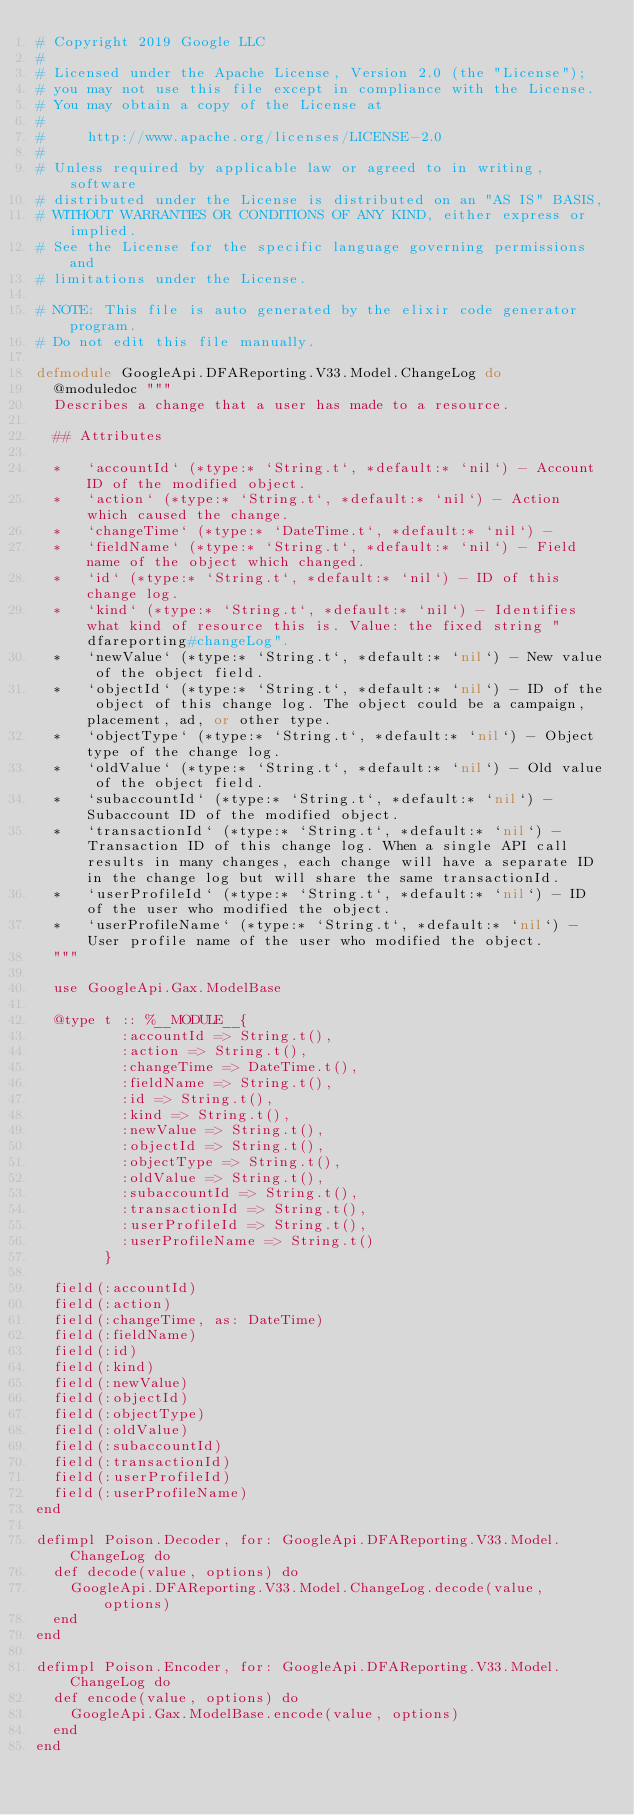Convert code to text. <code><loc_0><loc_0><loc_500><loc_500><_Elixir_># Copyright 2019 Google LLC
#
# Licensed under the Apache License, Version 2.0 (the "License");
# you may not use this file except in compliance with the License.
# You may obtain a copy of the License at
#
#     http://www.apache.org/licenses/LICENSE-2.0
#
# Unless required by applicable law or agreed to in writing, software
# distributed under the License is distributed on an "AS IS" BASIS,
# WITHOUT WARRANTIES OR CONDITIONS OF ANY KIND, either express or implied.
# See the License for the specific language governing permissions and
# limitations under the License.

# NOTE: This file is auto generated by the elixir code generator program.
# Do not edit this file manually.

defmodule GoogleApi.DFAReporting.V33.Model.ChangeLog do
  @moduledoc """
  Describes a change that a user has made to a resource.

  ## Attributes

  *   `accountId` (*type:* `String.t`, *default:* `nil`) - Account ID of the modified object.
  *   `action` (*type:* `String.t`, *default:* `nil`) - Action which caused the change.
  *   `changeTime` (*type:* `DateTime.t`, *default:* `nil`) - 
  *   `fieldName` (*type:* `String.t`, *default:* `nil`) - Field name of the object which changed.
  *   `id` (*type:* `String.t`, *default:* `nil`) - ID of this change log.
  *   `kind` (*type:* `String.t`, *default:* `nil`) - Identifies what kind of resource this is. Value: the fixed string "dfareporting#changeLog".
  *   `newValue` (*type:* `String.t`, *default:* `nil`) - New value of the object field.
  *   `objectId` (*type:* `String.t`, *default:* `nil`) - ID of the object of this change log. The object could be a campaign, placement, ad, or other type.
  *   `objectType` (*type:* `String.t`, *default:* `nil`) - Object type of the change log.
  *   `oldValue` (*type:* `String.t`, *default:* `nil`) - Old value of the object field.
  *   `subaccountId` (*type:* `String.t`, *default:* `nil`) - Subaccount ID of the modified object.
  *   `transactionId` (*type:* `String.t`, *default:* `nil`) - Transaction ID of this change log. When a single API call results in many changes, each change will have a separate ID in the change log but will share the same transactionId.
  *   `userProfileId` (*type:* `String.t`, *default:* `nil`) - ID of the user who modified the object.
  *   `userProfileName` (*type:* `String.t`, *default:* `nil`) - User profile name of the user who modified the object.
  """

  use GoogleApi.Gax.ModelBase

  @type t :: %__MODULE__{
          :accountId => String.t(),
          :action => String.t(),
          :changeTime => DateTime.t(),
          :fieldName => String.t(),
          :id => String.t(),
          :kind => String.t(),
          :newValue => String.t(),
          :objectId => String.t(),
          :objectType => String.t(),
          :oldValue => String.t(),
          :subaccountId => String.t(),
          :transactionId => String.t(),
          :userProfileId => String.t(),
          :userProfileName => String.t()
        }

  field(:accountId)
  field(:action)
  field(:changeTime, as: DateTime)
  field(:fieldName)
  field(:id)
  field(:kind)
  field(:newValue)
  field(:objectId)
  field(:objectType)
  field(:oldValue)
  field(:subaccountId)
  field(:transactionId)
  field(:userProfileId)
  field(:userProfileName)
end

defimpl Poison.Decoder, for: GoogleApi.DFAReporting.V33.Model.ChangeLog do
  def decode(value, options) do
    GoogleApi.DFAReporting.V33.Model.ChangeLog.decode(value, options)
  end
end

defimpl Poison.Encoder, for: GoogleApi.DFAReporting.V33.Model.ChangeLog do
  def encode(value, options) do
    GoogleApi.Gax.ModelBase.encode(value, options)
  end
end
</code> 